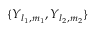<formula> <loc_0><loc_0><loc_500><loc_500>\{ Y _ { l _ { 1 } , m _ { 1 } } , Y _ { l _ { 2 } , m _ { 2 } } \}</formula> 